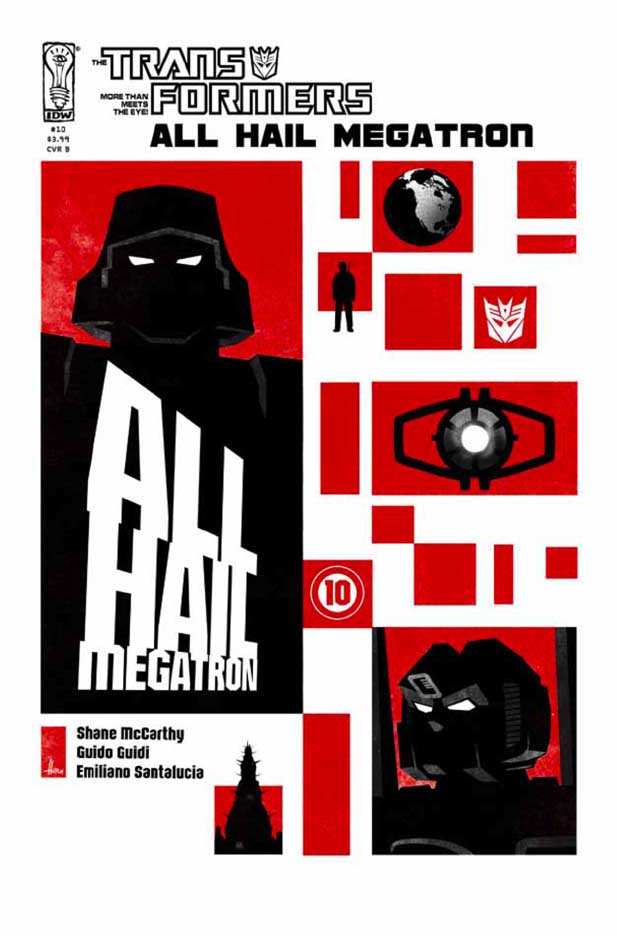What hidden secrets or messages might the geometric patterns on the cover hide? The geometric patterns on the cover might hold subtle secrets or messages related to the narrative. For instance, the alignment and placement of these shapes could symbolize strategic points or plans of the Decepticons. The parallel lines and grids could reference schematics or tactical maps essential to Megatron's conquest. Additionally, certain patterns could be ciphers or glyphs representing lore and hidden histories, offering deeper insights for the keen observer. These elements elevate the cover from mere decoration to a clever puzzle, inviting fans to decode and unravel its intricacies. 